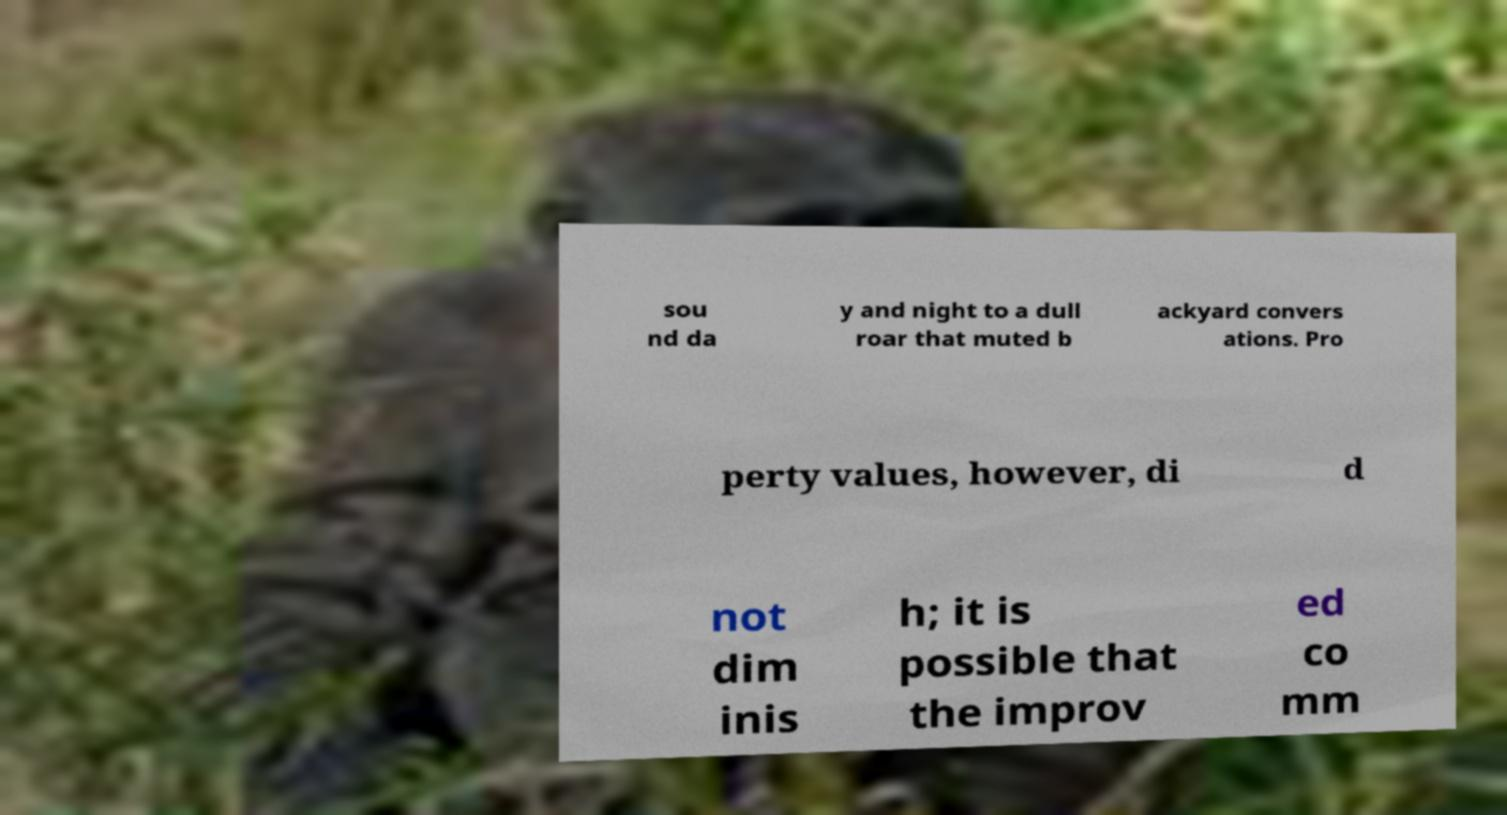Could you extract and type out the text from this image? sou nd da y and night to a dull roar that muted b ackyard convers ations. Pro perty values, however, di d not dim inis h; it is possible that the improv ed co mm 